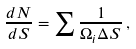Convert formula to latex. <formula><loc_0><loc_0><loc_500><loc_500>\frac { d N } { d S } = \sum { \frac { 1 } { \Omega _ { i } \Delta S } } \, ,</formula> 